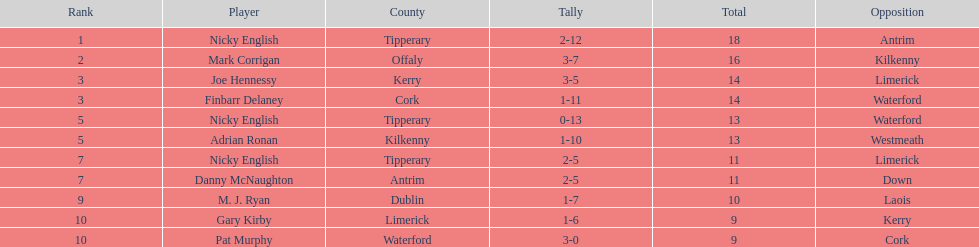What was the mean of the sums of nicky english and mark corrigan? 17. 